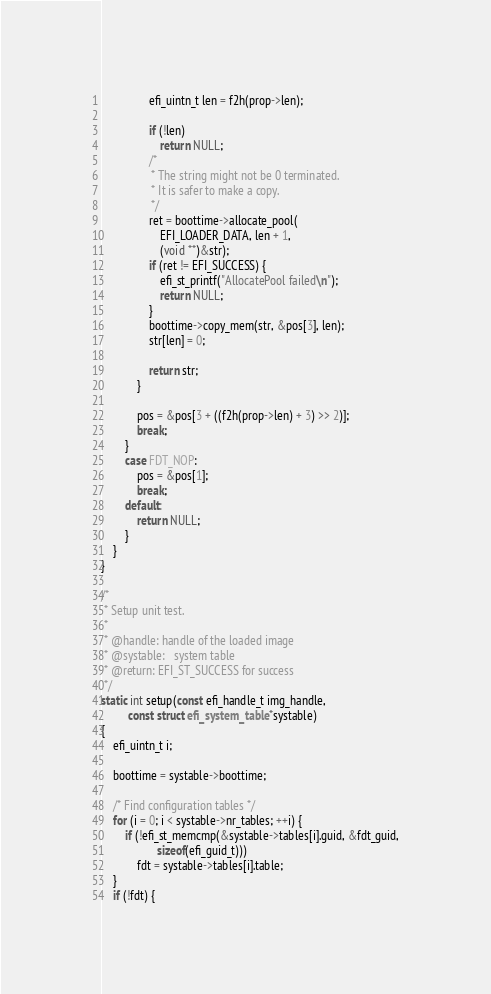<code> <loc_0><loc_0><loc_500><loc_500><_C_>				efi_uintn_t len = f2h(prop->len);

				if (!len)
					return NULL;
				/*
				 * The string might not be 0 terminated.
				 * It is safer to make a copy.
				 */
				ret = boottime->allocate_pool(
					EFI_LOADER_DATA, len + 1,
					(void **)&str);
				if (ret != EFI_SUCCESS) {
					efi_st_printf("AllocatePool failed\n");
					return NULL;
				}
				boottime->copy_mem(str, &pos[3], len);
				str[len] = 0;

				return str;
			}

			pos = &pos[3 + ((f2h(prop->len) + 3) >> 2)];
			break;
		}
		case FDT_NOP:
			pos = &pos[1];
			break;
		default:
			return NULL;
		}
	}
}

/*
 * Setup unit test.
 *
 * @handle:	handle of the loaded image
 * @systable:	system table
 * @return:	EFI_ST_SUCCESS for success
 */
static int setup(const efi_handle_t img_handle,
		 const struct efi_system_table *systable)
{
	efi_uintn_t i;

	boottime = systable->boottime;

	/* Find configuration tables */
	for (i = 0; i < systable->nr_tables; ++i) {
		if (!efi_st_memcmp(&systable->tables[i].guid, &fdt_guid,
				   sizeof(efi_guid_t)))
			fdt = systable->tables[i].table;
	}
	if (!fdt) {</code> 